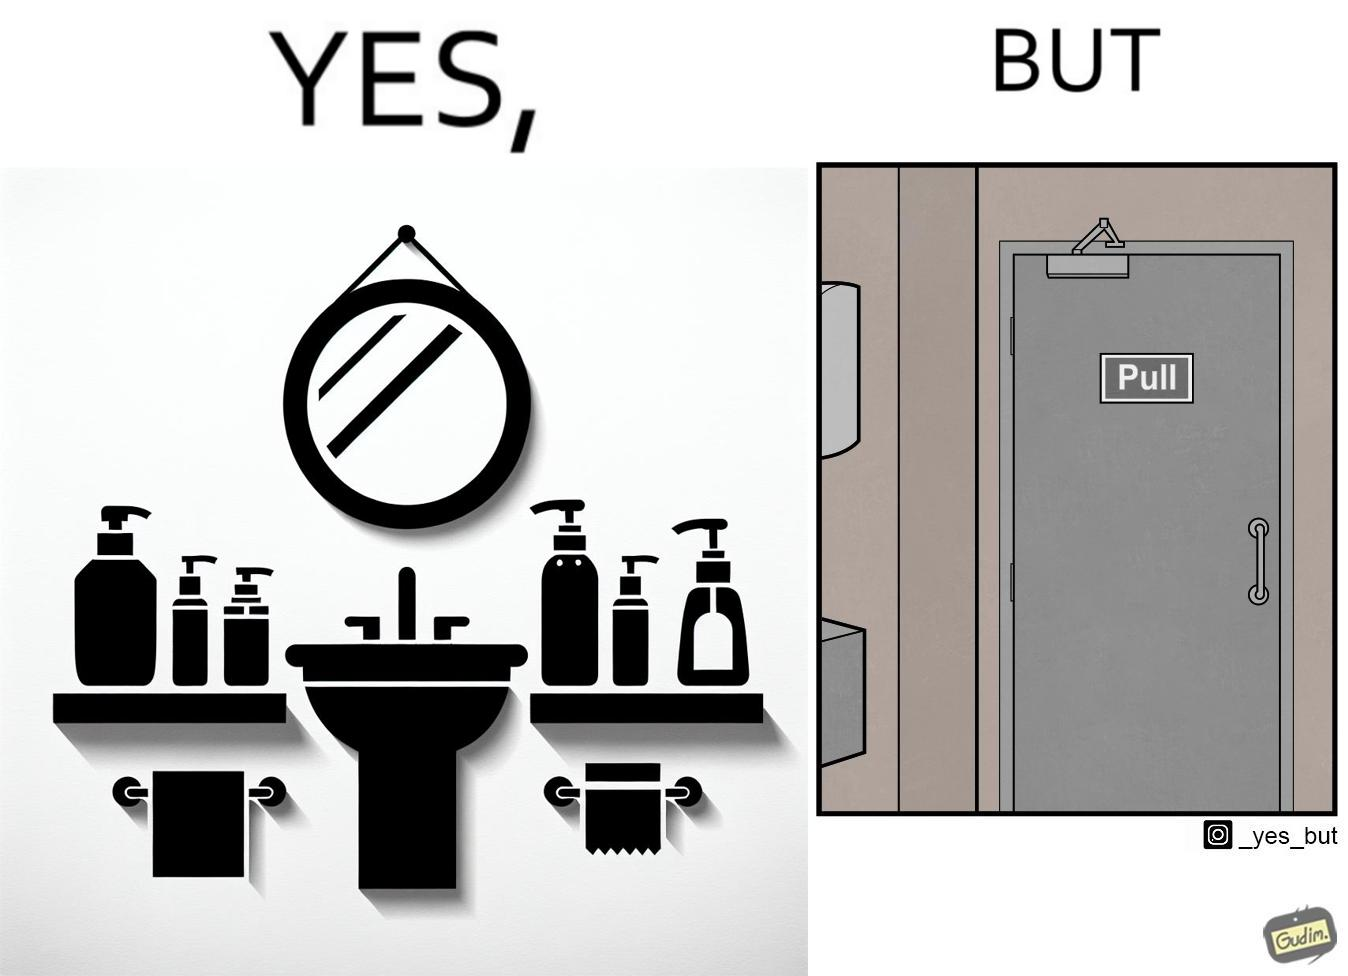Provide a description of this image. The image is ironic, because in the first image in the bathroom there are so many things to clean hands around the basin but in the same bathroom people have to open the doors by hand which can easily spread the germs or bacteria even after times of hand cleaning as there is no way to open it without hands 